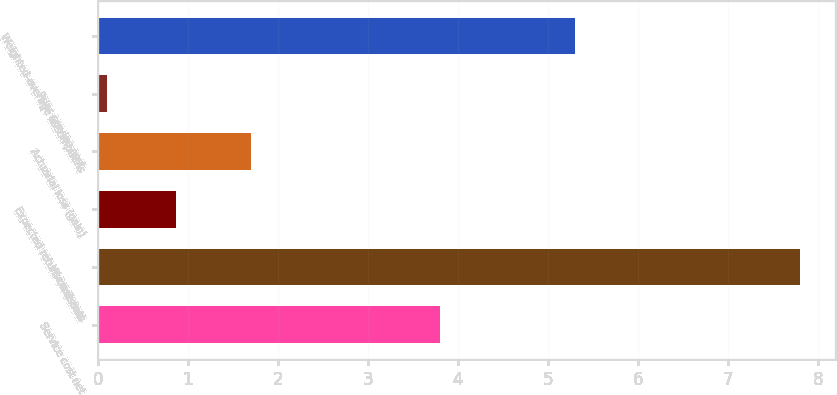Convert chart to OTSL. <chart><loc_0><loc_0><loc_500><loc_500><bar_chart><fcel>Service cost net<fcel>Interest cost<fcel>Expected return on assets<fcel>Actuarial loss (gain)<fcel>Prior service cost<fcel>Weighted-average assumptions<nl><fcel>3.8<fcel>7.8<fcel>0.87<fcel>1.7<fcel>0.1<fcel>5.3<nl></chart> 